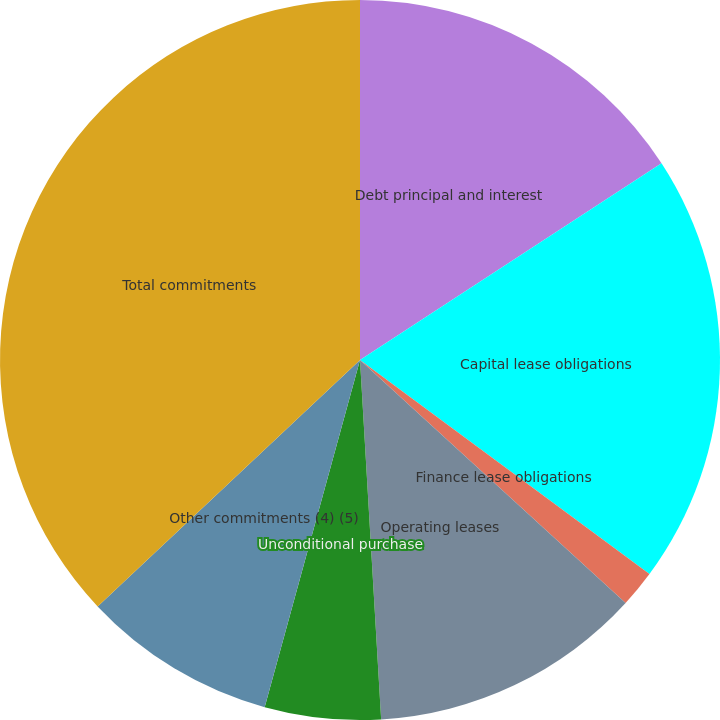Convert chart to OTSL. <chart><loc_0><loc_0><loc_500><loc_500><pie_chart><fcel>Debt principal and interest<fcel>Capital lease obligations<fcel>Finance lease obligations<fcel>Operating leases<fcel>Unconditional purchase<fcel>Other commitments (4) (5)<fcel>Total commitments<nl><fcel>15.8%<fcel>19.33%<fcel>1.66%<fcel>12.27%<fcel>5.2%<fcel>8.73%<fcel>37.0%<nl></chart> 